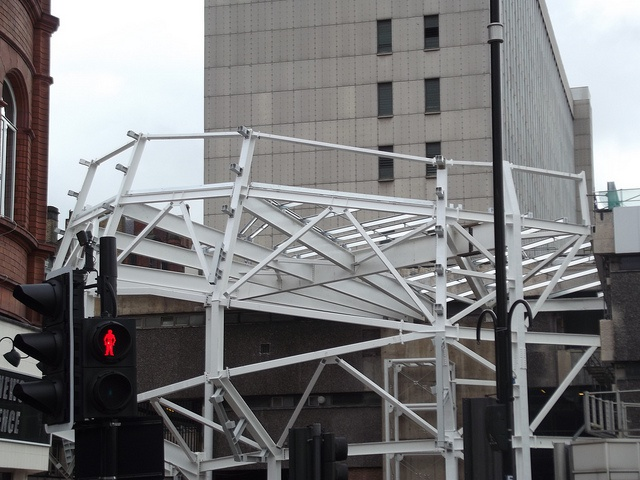Describe the objects in this image and their specific colors. I can see traffic light in black and gray tones, traffic light in black, red, maroon, and brown tones, traffic light in black, gray, and darkgray tones, and traffic light in black and darkgray tones in this image. 